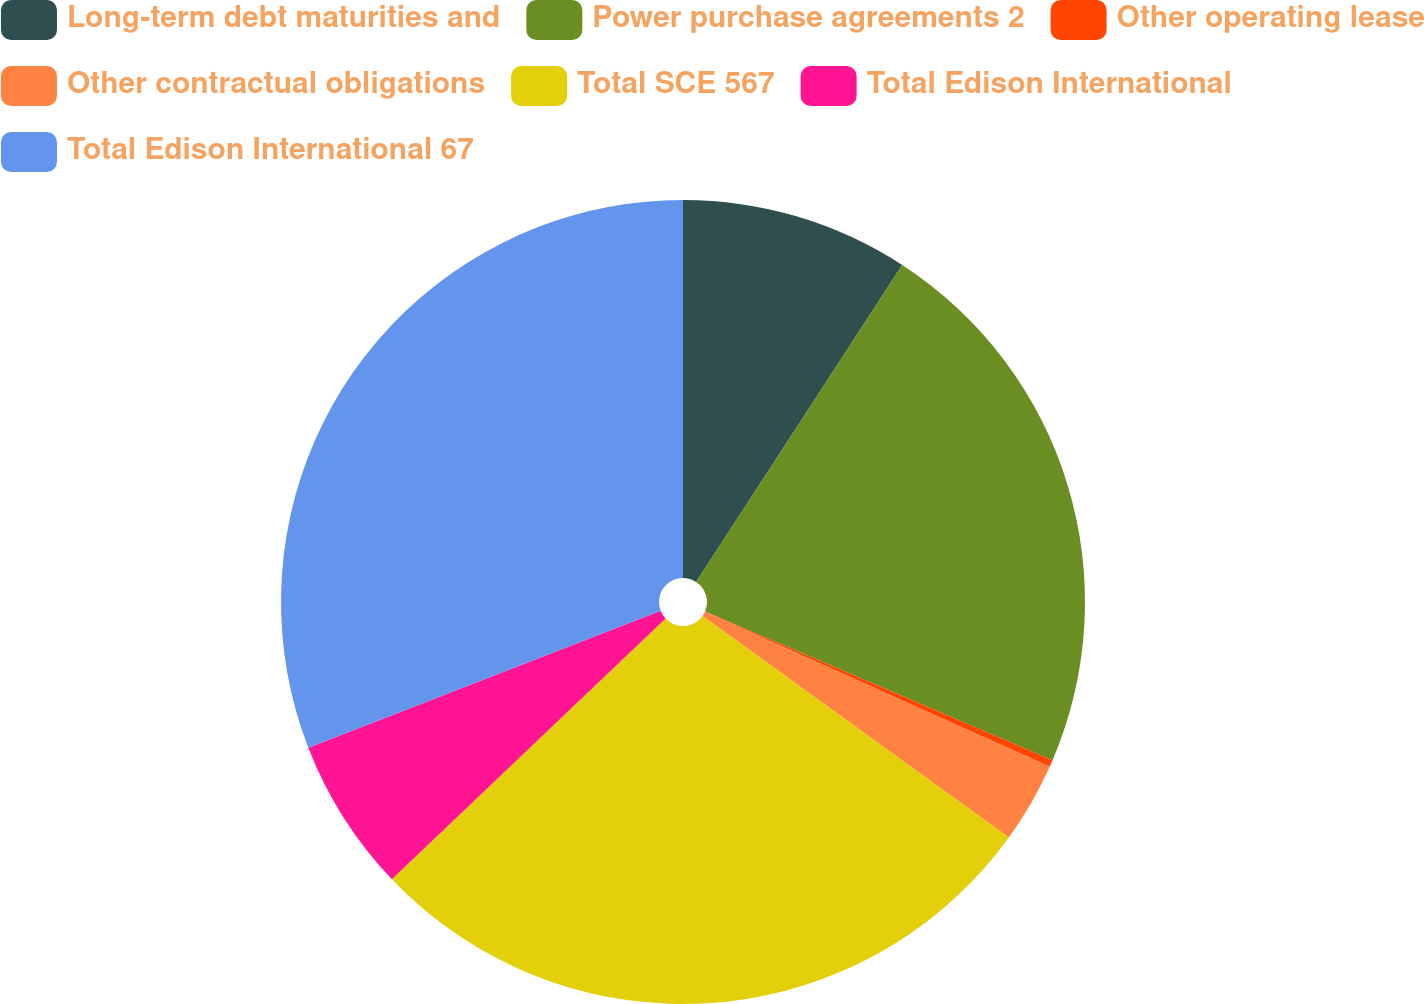<chart> <loc_0><loc_0><loc_500><loc_500><pie_chart><fcel>Long-term debt maturities and<fcel>Power purchase agreements 2<fcel>Other operating lease<fcel>Other contractual obligations<fcel>Total SCE 567<fcel>Total Edison International<fcel>Total Edison International 67<nl><fcel>9.18%<fcel>22.26%<fcel>0.28%<fcel>3.24%<fcel>27.93%<fcel>6.21%<fcel>30.9%<nl></chart> 